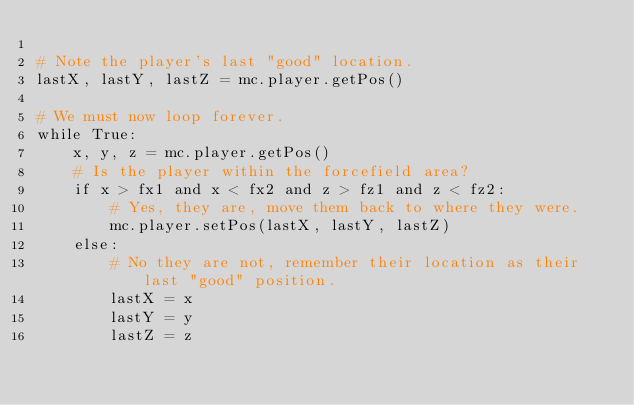Convert code to text. <code><loc_0><loc_0><loc_500><loc_500><_Python_>
# Note the player's last "good" location.
lastX, lastY, lastZ = mc.player.getPos()

# We must now loop forever.
while True:
    x, y, z = mc.player.getPos()
    # Is the player within the forcefield area?
    if x > fx1 and x < fx2 and z > fz1 and z < fz2:
        # Yes, they are, move them back to where they were.
        mc.player.setPos(lastX, lastY, lastZ)
    else:
        # No they are not, remember their location as their last "good" position.
        lastX = x
        lastY = y
        lastZ = z
</code> 